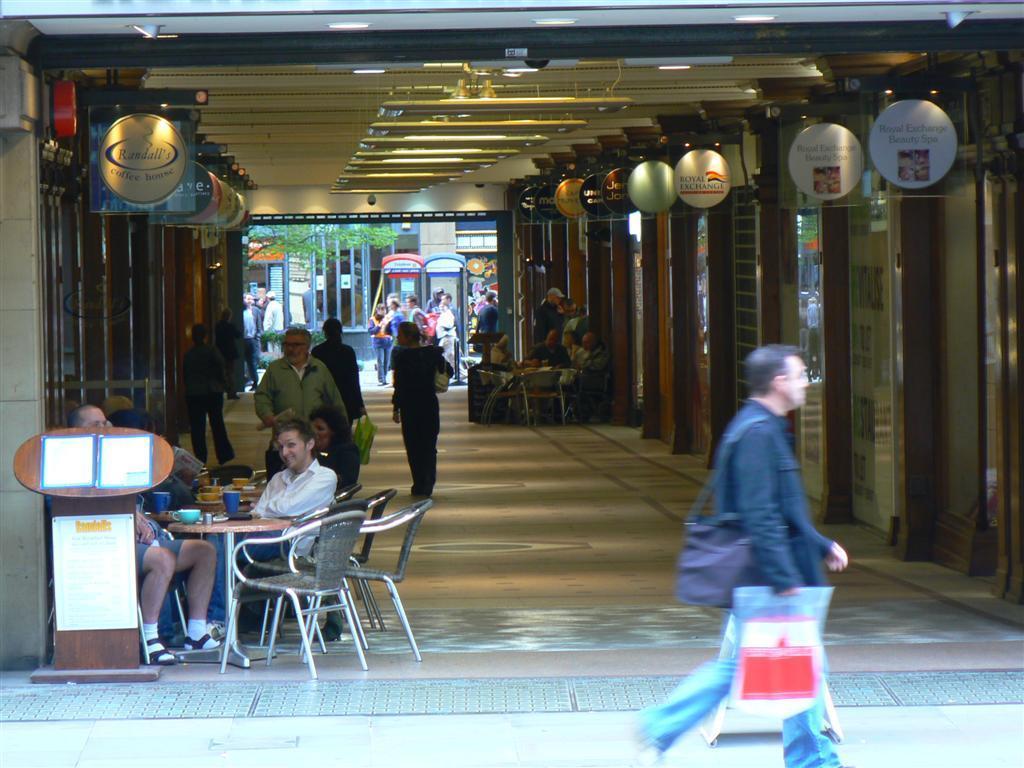Could you give a brief overview of what you see in this image? In this picture we can see a person is walking his holding a cover and he has a backpack there is a way in the shopping mall and some people are walking some group of persons are sitting here and there is a table some boats are present in there is a tree back side. 